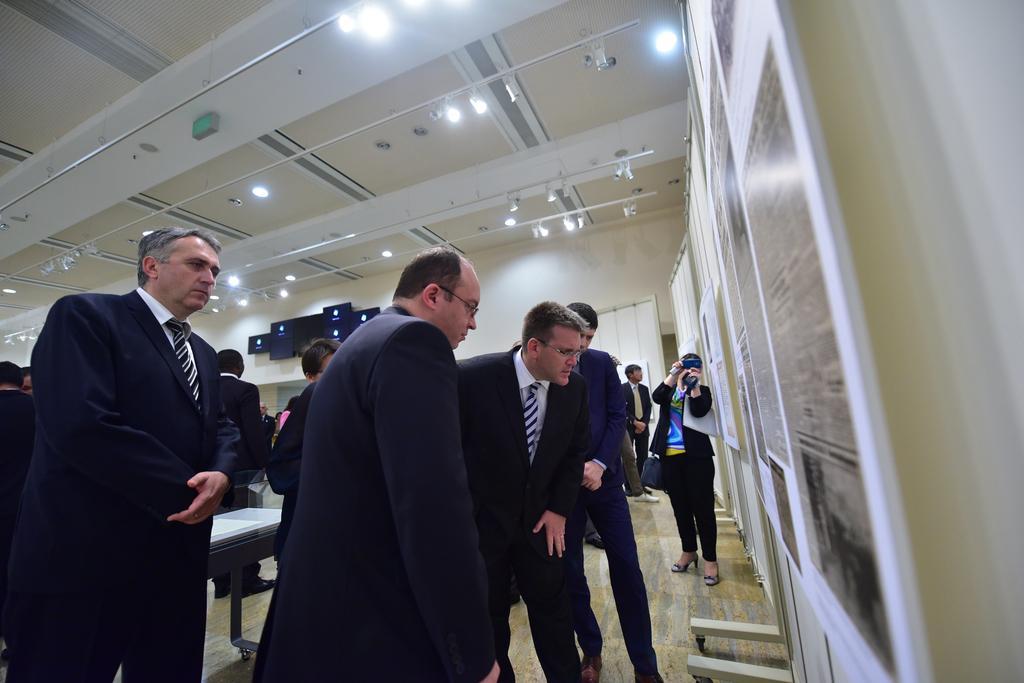Please provide a concise description of this image. In this image I can see the group of people with different color dresses. In-front of these people I can see the boards to the wall. I can see the table in-between these people. In the background I can see few more boards, curtains and the lights in the top. 